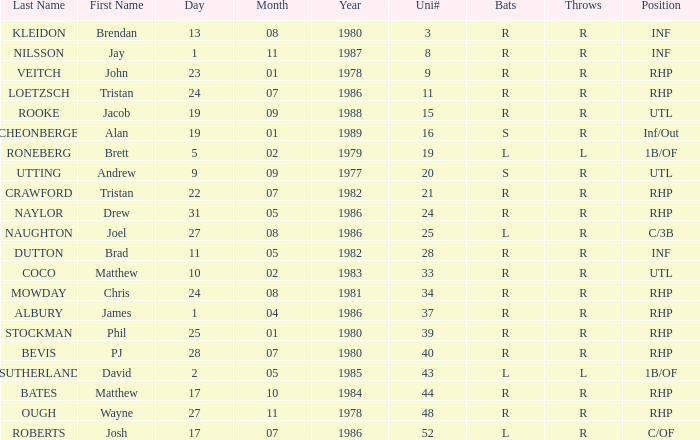How many Uni numbers have Bats of s, and a Position of utl? 1.0. 